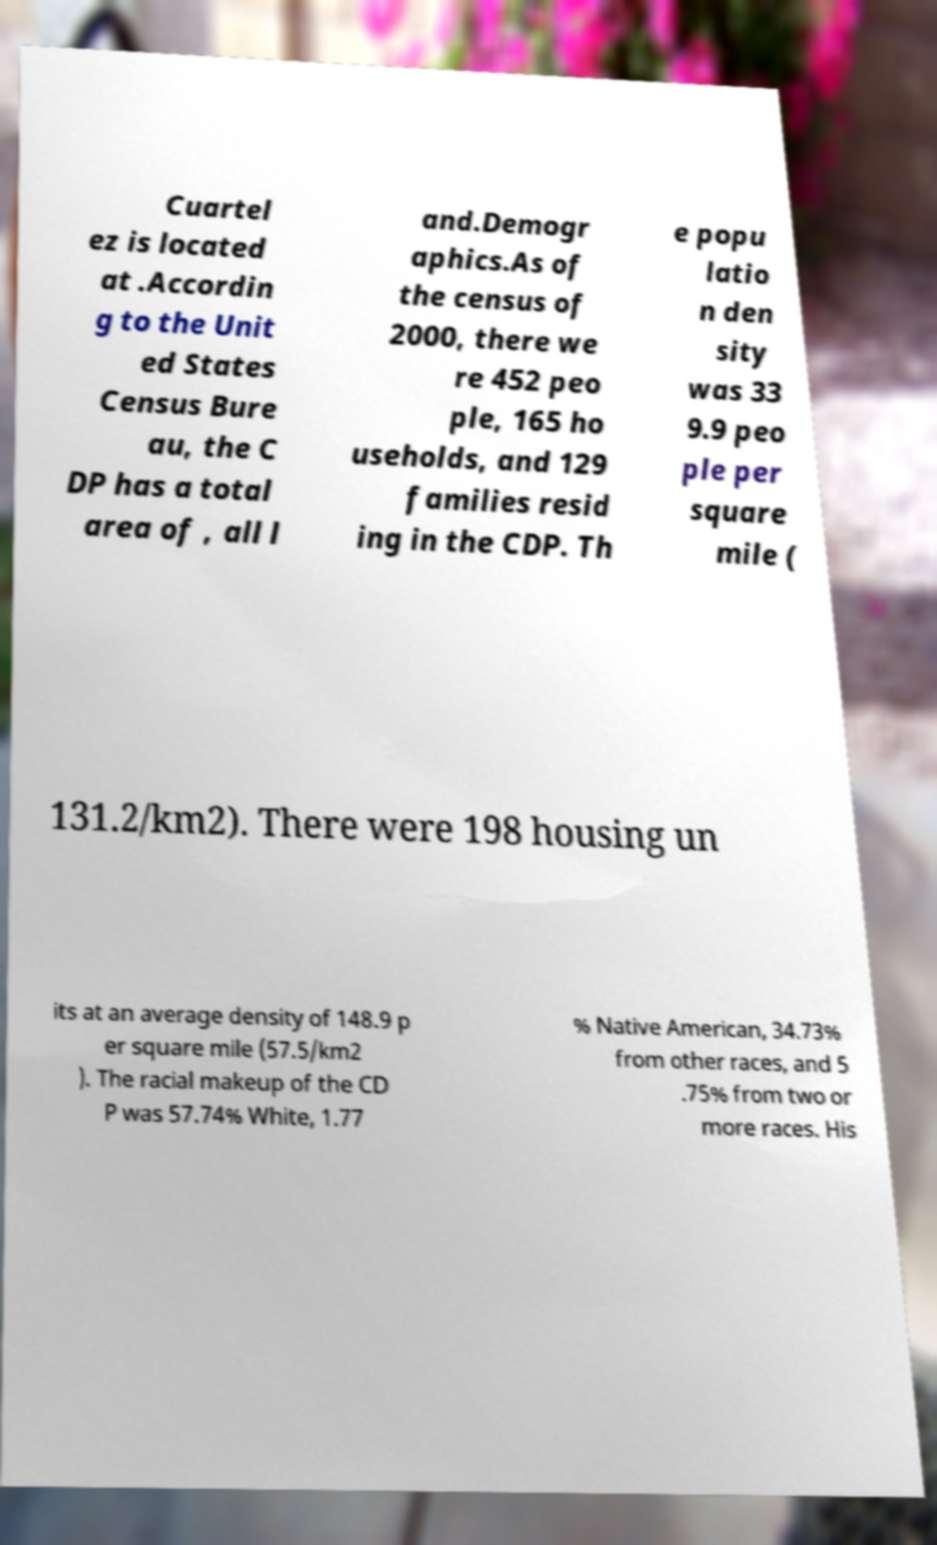I need the written content from this picture converted into text. Can you do that? Cuartel ez is located at .Accordin g to the Unit ed States Census Bure au, the C DP has a total area of , all l and.Demogr aphics.As of the census of 2000, there we re 452 peo ple, 165 ho useholds, and 129 families resid ing in the CDP. Th e popu latio n den sity was 33 9.9 peo ple per square mile ( 131.2/km2). There were 198 housing un its at an average density of 148.9 p er square mile (57.5/km2 ). The racial makeup of the CD P was 57.74% White, 1.77 % Native American, 34.73% from other races, and 5 .75% from two or more races. His 